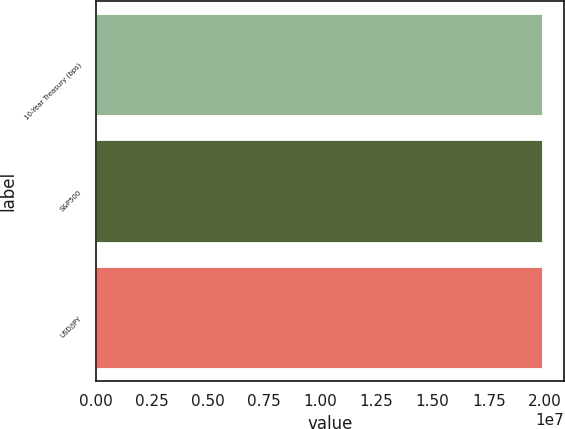Convert chart. <chart><loc_0><loc_0><loc_500><loc_500><bar_chart><fcel>10-Year Treasury (bps)<fcel>S&P500<fcel>USD/JPY<nl><fcel>1.9872e+07<fcel>1.9872e+07<fcel>1.9872e+07<nl></chart> 